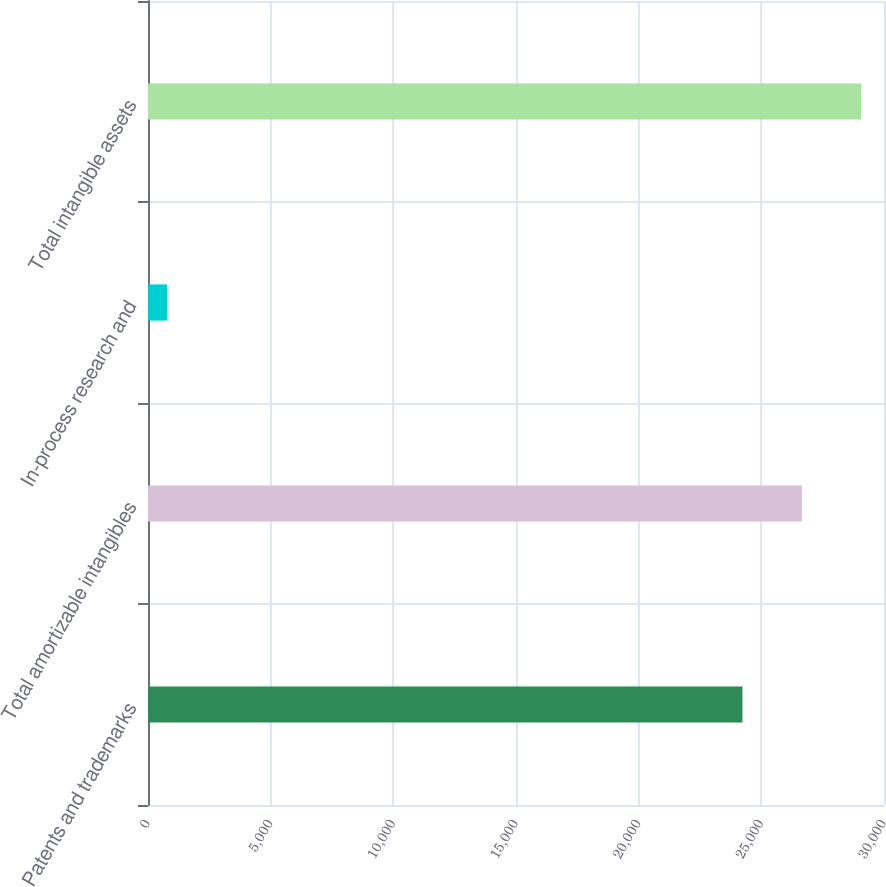Convert chart. <chart><loc_0><loc_0><loc_500><loc_500><bar_chart><fcel>Patents and trademarks<fcel>Total amortizable intangibles<fcel>In-process research and<fcel>Total intangible assets<nl><fcel>24230<fcel>26653<fcel>780<fcel>29076<nl></chart> 